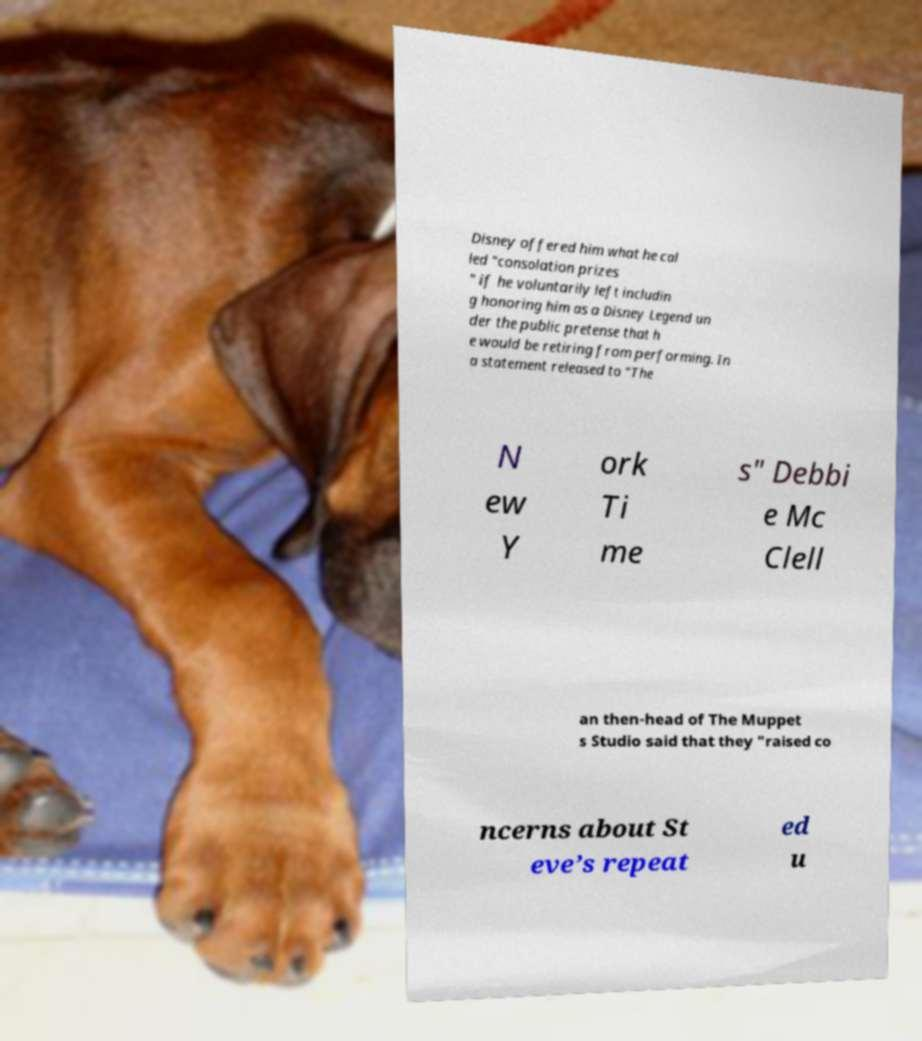Can you read and provide the text displayed in the image?This photo seems to have some interesting text. Can you extract and type it out for me? Disney offered him what he cal led "consolation prizes " if he voluntarily left includin g honoring him as a Disney Legend un der the public pretense that h e would be retiring from performing. In a statement released to "The N ew Y ork Ti me s" Debbi e Mc Clell an then-head of The Muppet s Studio said that they "raised co ncerns about St eve’s repeat ed u 